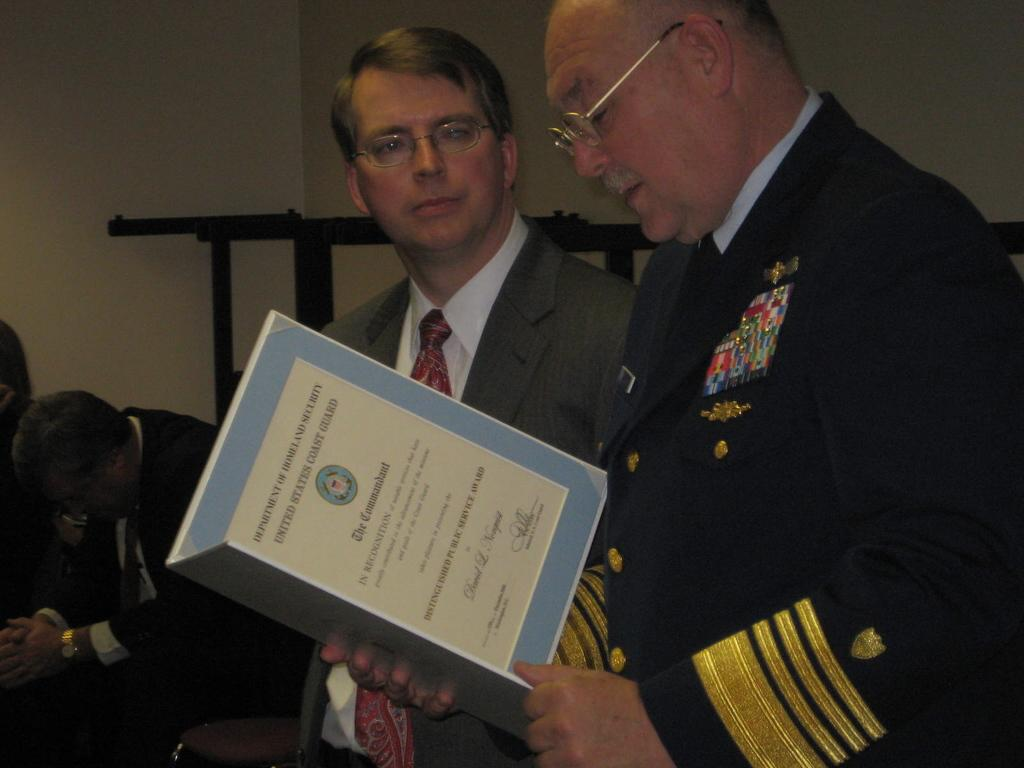How many people are in the image? There are people in the image. What are the people wearing? The people are wearing clothes. Can you describe the person on the right side of the image? The person on the right side is holding a file with his hands. What is in front of the wall in the image? There is an object in front of the wall. What type of rat can be seen interacting with the person holding the file in the image? There is no rat present in the image, and therefore no such interaction can be observed. What muscle is the person on the right side of the image flexing while holding the file? The image does not provide information about the person's muscles, so it cannot be determined which muscle is being flexed. 